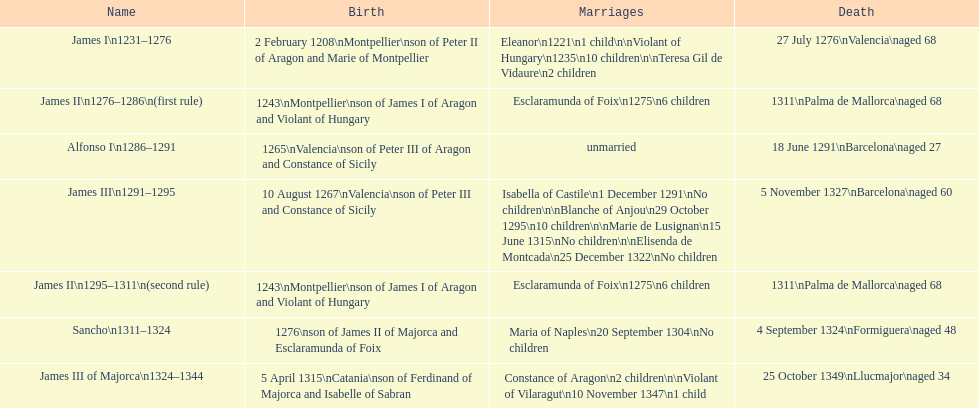What was the length of james ii's rule, taking into account his second reign? 26 years. 